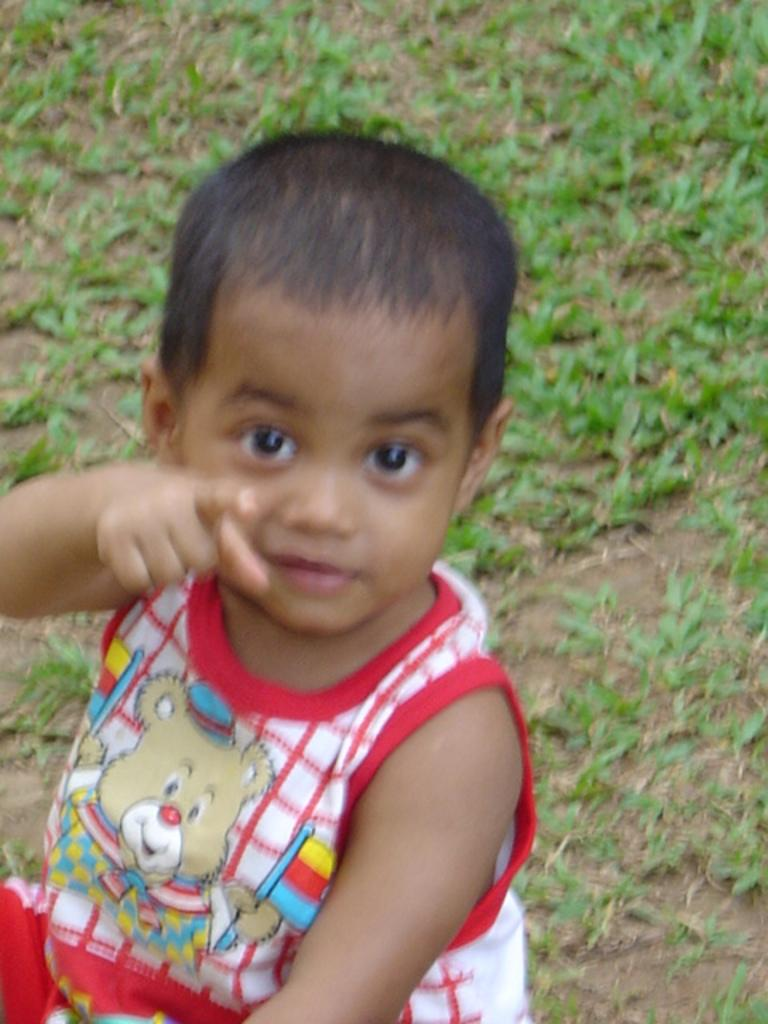What is the main subject of the image? The main subject of the image is a kid. What type of natural environment can be seen in the background of the image? There is grass visible in the background of the image. What type of organization is the kid a part of in the image? There is no indication in the image that the kid is a part of any organization. What type of toys can be seen in the image? There is no mention of toys in the provided facts, so we cannot determine if any toys are present in the image. 